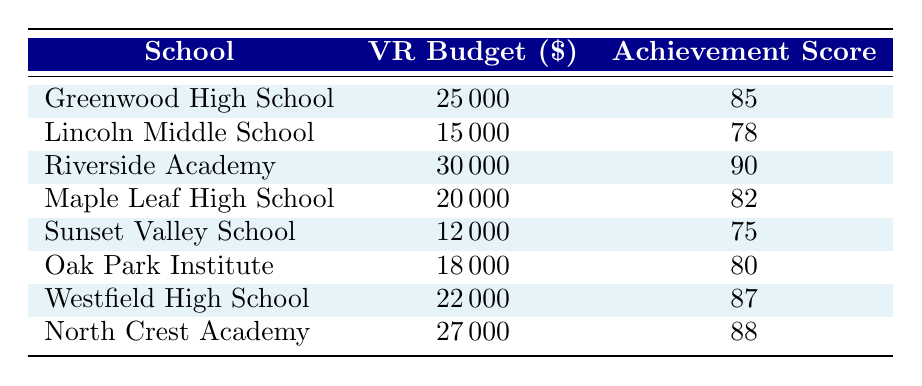What is the achievement score of Riverside Academy? The table lists Riverside Academy with a student achievement score of 90.
Answer: 90 Which school has the highest budget allocation for VR? Riverside Academy has the highest budget allocation for VR, which is 30000.
Answer: 30000 What is the average achievement score for the schools listed? To find the average achievement score, add all the scores together: (85 + 78 + 90 + 82 + 75 + 80 + 87 + 88) =  705. There are 8 schools, so the average is 705 / 8 = 88.125.
Answer: 88.125 Is the budget allocation directly proportional to student achievement scores in this table? Analyzing the pairs of budget allocation and achievement scores reveals some schools with lower budgets achieving higher scores and vice versa, indicating that there is no direct proportionality.
Answer: No Which school has a budget allocation that is more than 20000 but less than 27000? Westfield High School has a budget allocation of 22000, which falls within that range.
Answer: Westfield High School What is the difference in achievement scores between the highest and the lowest performing school? The highest achievement score is 90 (Riverside Academy) and the lowest is 75 (Sunset Valley School). The difference is 90 - 75 = 15.
Answer: 15 Do two schools have the same budget allocation for VR resources? Each school in the list has a unique budget allocation, so no two schools share the same amount.
Answer: No What is the total budget allocated for VR across all schools listed? To find the total budget, sum the budget allocations: 25000 + 15000 + 30000 + 20000 + 12000 + 18000 + 22000 + 27000 = 169000.
Answer: 169000 Which school has a higher achievement score, Lincoln Middle School or Oak Park Institute? Lincoln Middle School has an achievement score of 78, while Oak Park Institute has 80, so Oak Park Institute has the higher score.
Answer: Oak Park Institute 